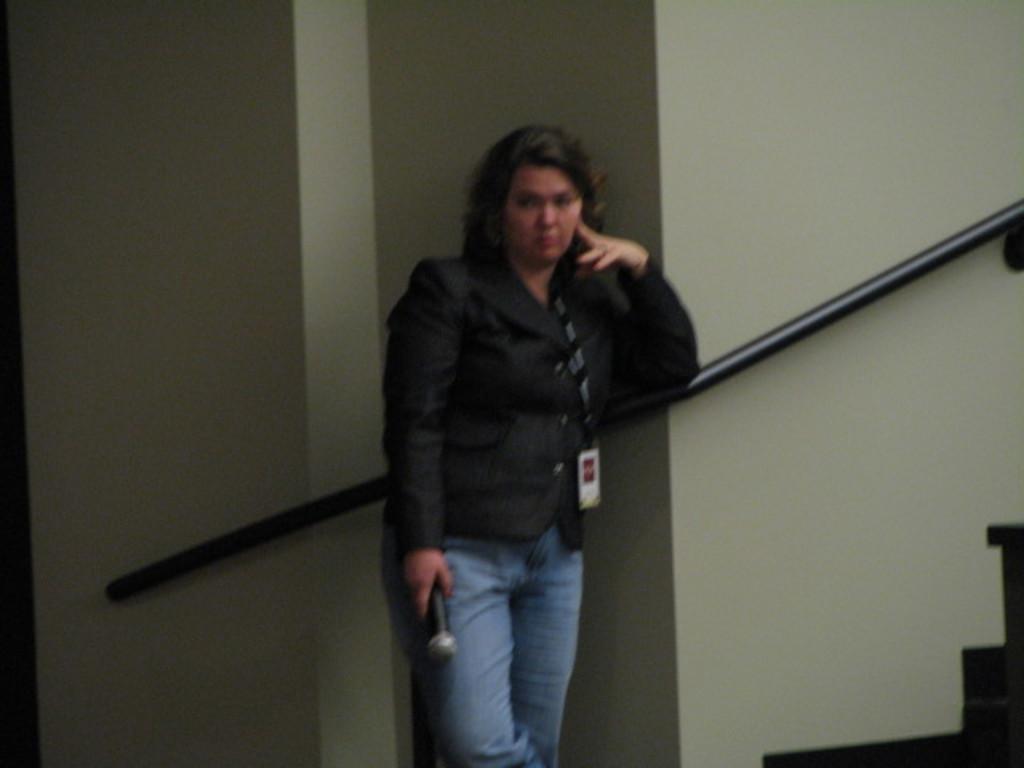Can you describe this image briefly? In the image we can see there is a woman standing and holding mic in her hand. She is wearing id card in her neck and she is standing near the stairs. There is an iron rod attached to the wall. 